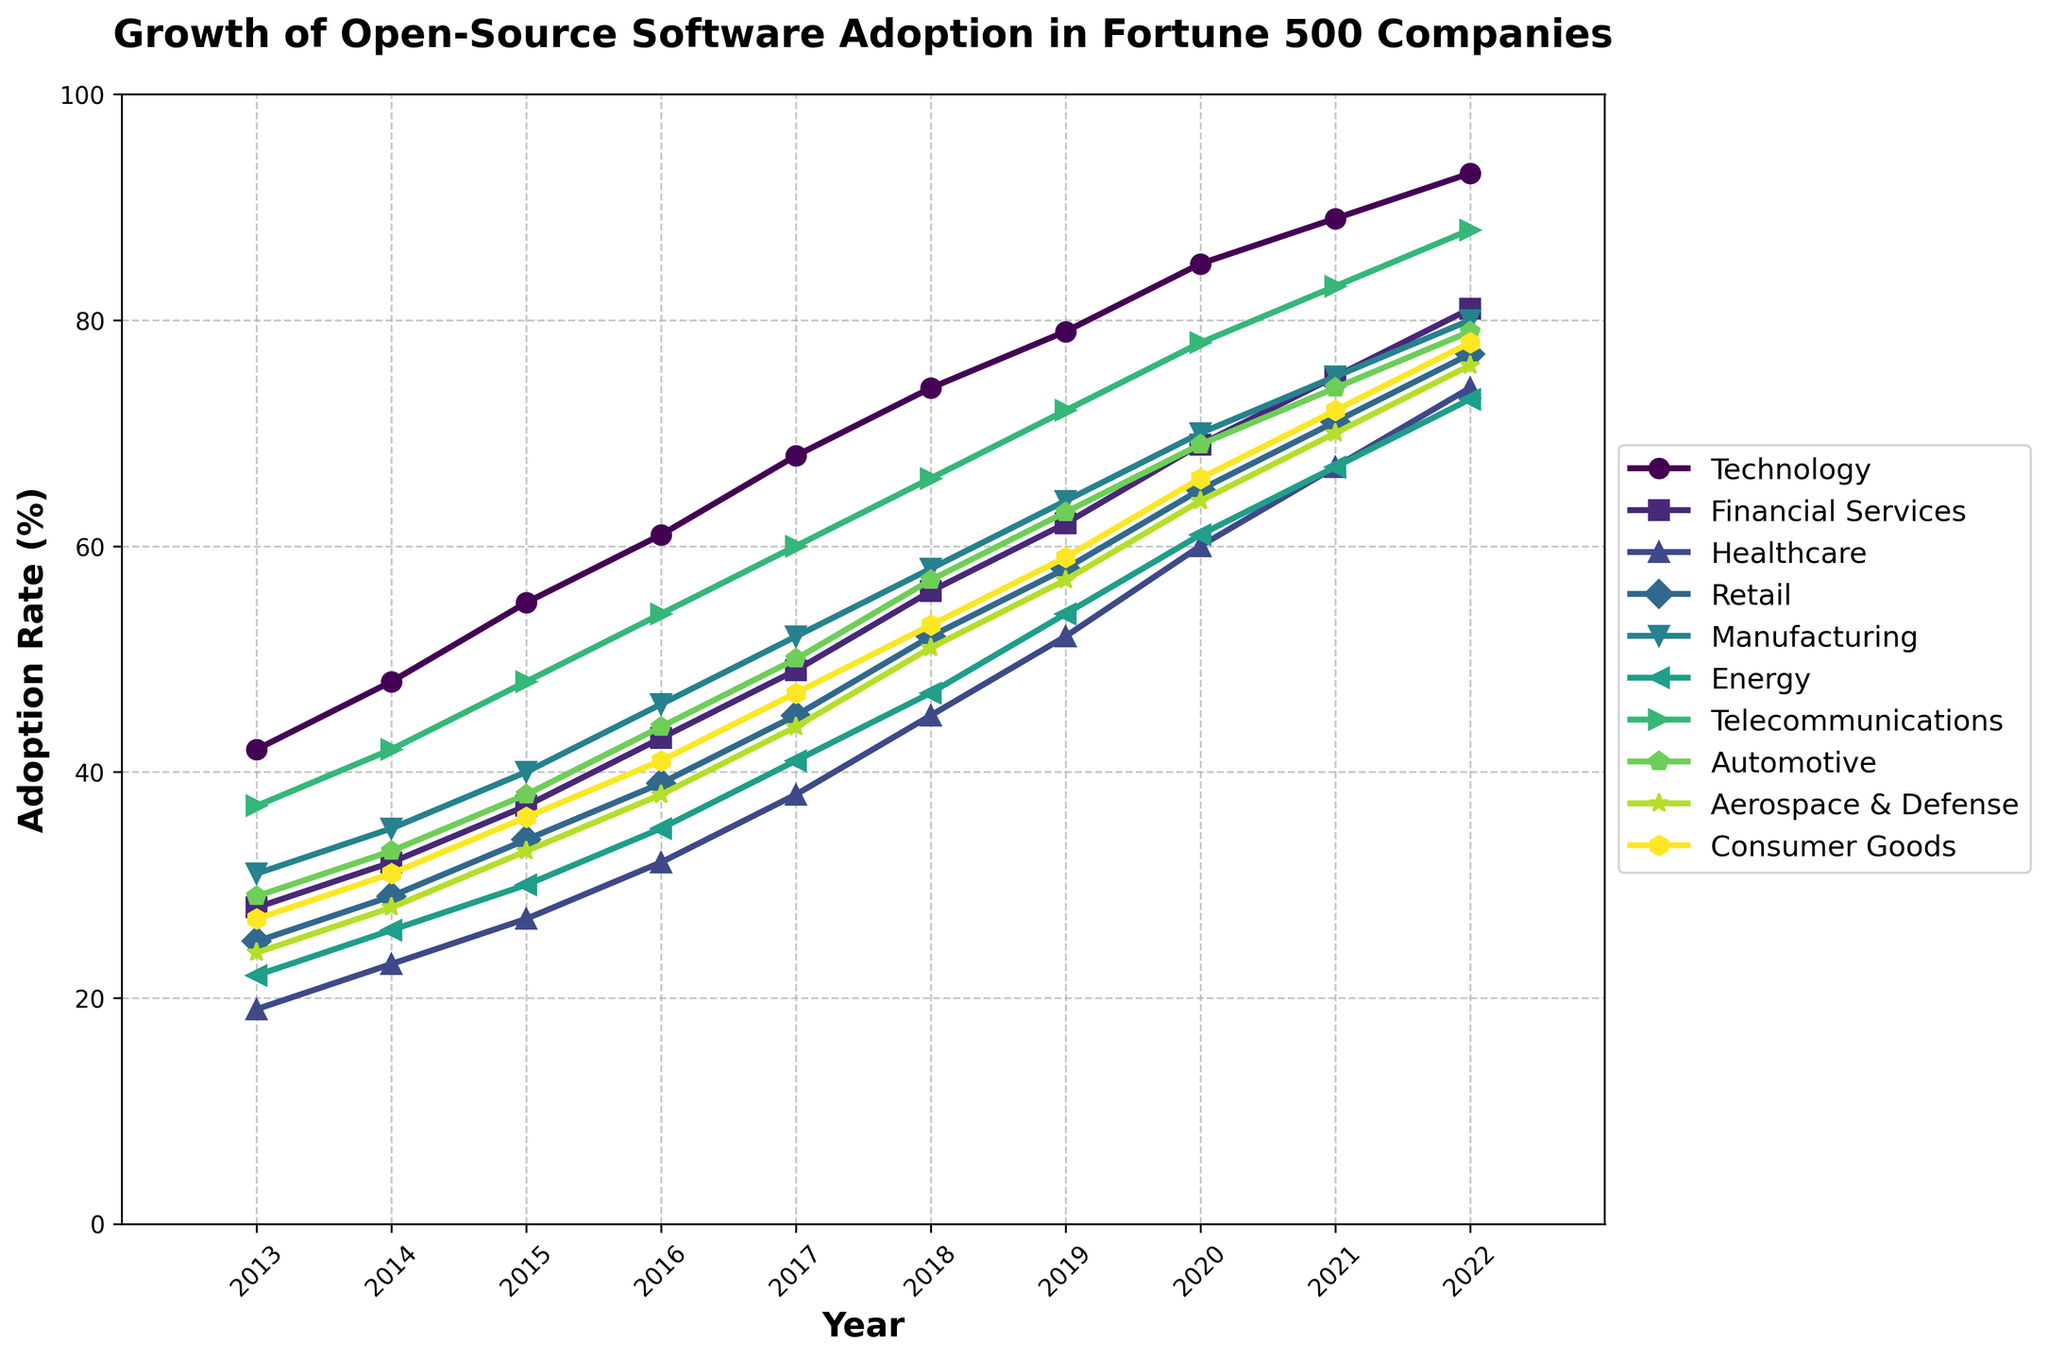What industry had the highest adoption rate in 2022? To find the industry with the highest adoption rate in 2022, look at the adoption rates for all industries in that year. The technology industry has the highest rate at 93%.
Answer: Technology Which two industries had the closest adoption rates in 2020? To determine which two industries had the closest adoption rates in 2020, compare the rates for each industry. Financial Services and Aerospace & Defense both have close rates of 69% and 64%, respectively. They are the closest pair.
Answer: Financial Services and Aerospace & Defense By how many percentage points did the healthcare adoption rate increase from 2013 to 2022? To compute the percentage increase for healthcare from 2013 to 2022, subtract the 2013 rate from the 2022 rate. The 2022 rate is 74%, and the 2013 rate is 19%, so the increase is 74% - 19% = 55 percentage points.
Answer: 55 Which industry showed the most consistent yearly growth between 2013 and 2022? To find the industry with the most consistent yearly growth, visually assess the smoothness and steadiness of the lines representing each industry's growth. The technology industry shows a consistently upward trend without sharp fluctuations.
Answer: Technology Did any industry reach an 80% adoption rate by 2020? To determine if any industry reached 80% adoption rate by 2020, check the 2020 adoption rates for all industries. None of the industries reached 80% by 2020. The closest was Technology at 85%.
Answer: No What is the difference in the adoption rate between Retail and Energy in 2017? To find the difference in adoption rate between Retail and Energy in 2017, subtract the adoption rate of Energy from that of Retail. Retail in 2017 is 45%, while Energy is 41%. The difference is 45% - 41% = 4 percentage points.
Answer: 4 Compare the adoption rates of the Automotive and Telecommunications industries in 2022. Which one was higher and by how much? To compare adoption rates for Automotive and Telecommunications industries in 2022, look at their respective rates. Telecommunications had 88% while Automotive had 79%. The difference is 88% - 79% = 9 percentage points, making Telecommunications higher by 9%.
Answer: Telecommunications by 9 Which industry had the largest adoption rate increase during any single year? To find the industry with the largest single-year increase, compare the yearly deltas for all industries. Healthcare showed an increase from 38% in 2017 to 45% in 2018, which is a 7 percentage point increase, the highest among the years for any industry.
Answer: Healthcare Which year did the Manufacturing industry reach a 70% adoption rate? Check the adoption rates across the years for the Manufacturing industry; it reached around 70% in 2020.
Answer: 2020 